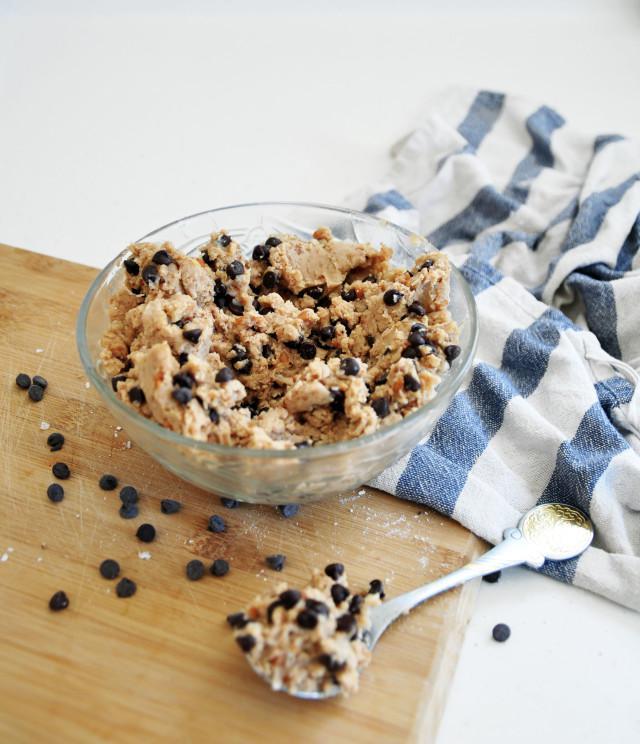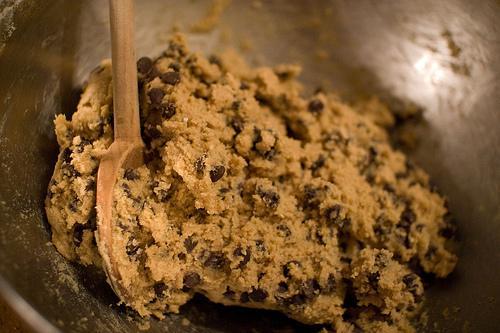The first image is the image on the left, the second image is the image on the right. Assess this claim about the two images: "The image on the right contains a bowl of cookie dough with a wooden spoon in it.". Correct or not? Answer yes or no. Yes. The first image is the image on the left, the second image is the image on the right. Considering the images on both sides, is "Both images show unfinished cookie dough with chocolate chips." valid? Answer yes or no. Yes. 